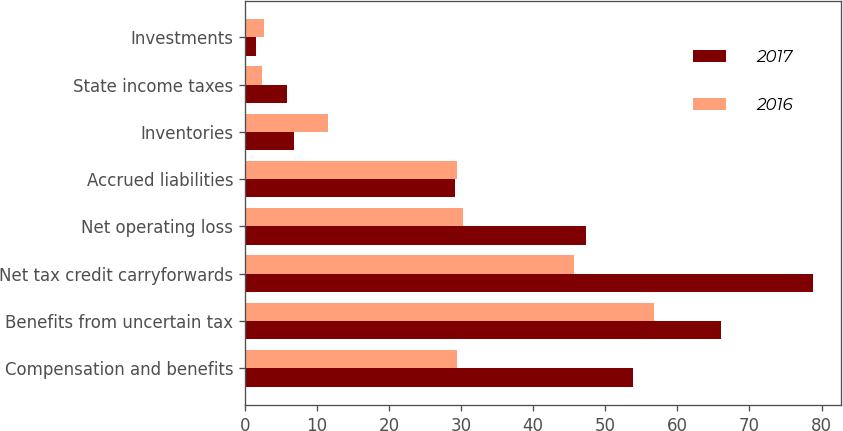Convert chart to OTSL. <chart><loc_0><loc_0><loc_500><loc_500><stacked_bar_chart><ecel><fcel>Compensation and benefits<fcel>Benefits from uncertain tax<fcel>Net tax credit carryforwards<fcel>Net operating loss<fcel>Accrued liabilities<fcel>Inventories<fcel>State income taxes<fcel>Investments<nl><fcel>2017<fcel>53.9<fcel>66.1<fcel>78.8<fcel>47.3<fcel>29.2<fcel>6.8<fcel>5.8<fcel>1.6<nl><fcel>2016<fcel>29.4<fcel>56.7<fcel>45.6<fcel>30.2<fcel>29.4<fcel>11.5<fcel>2.4<fcel>2.6<nl></chart> 